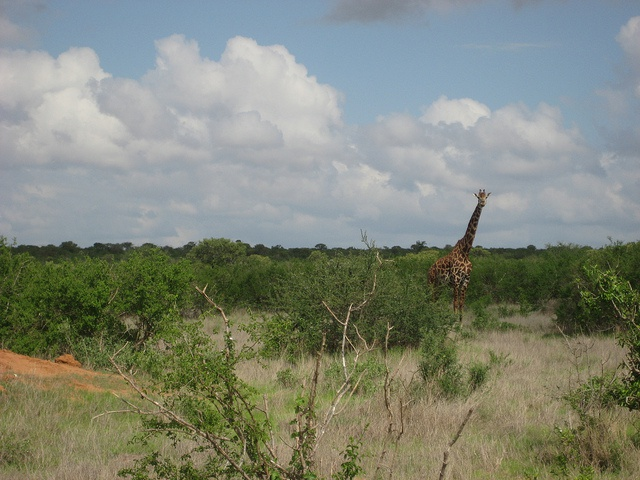Describe the objects in this image and their specific colors. I can see a giraffe in gray, black, and maroon tones in this image. 